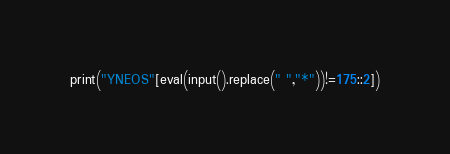Convert code to text. <code><loc_0><loc_0><loc_500><loc_500><_Python_>print("YNEOS"[eval(input().replace(" ","*"))!=175::2])</code> 